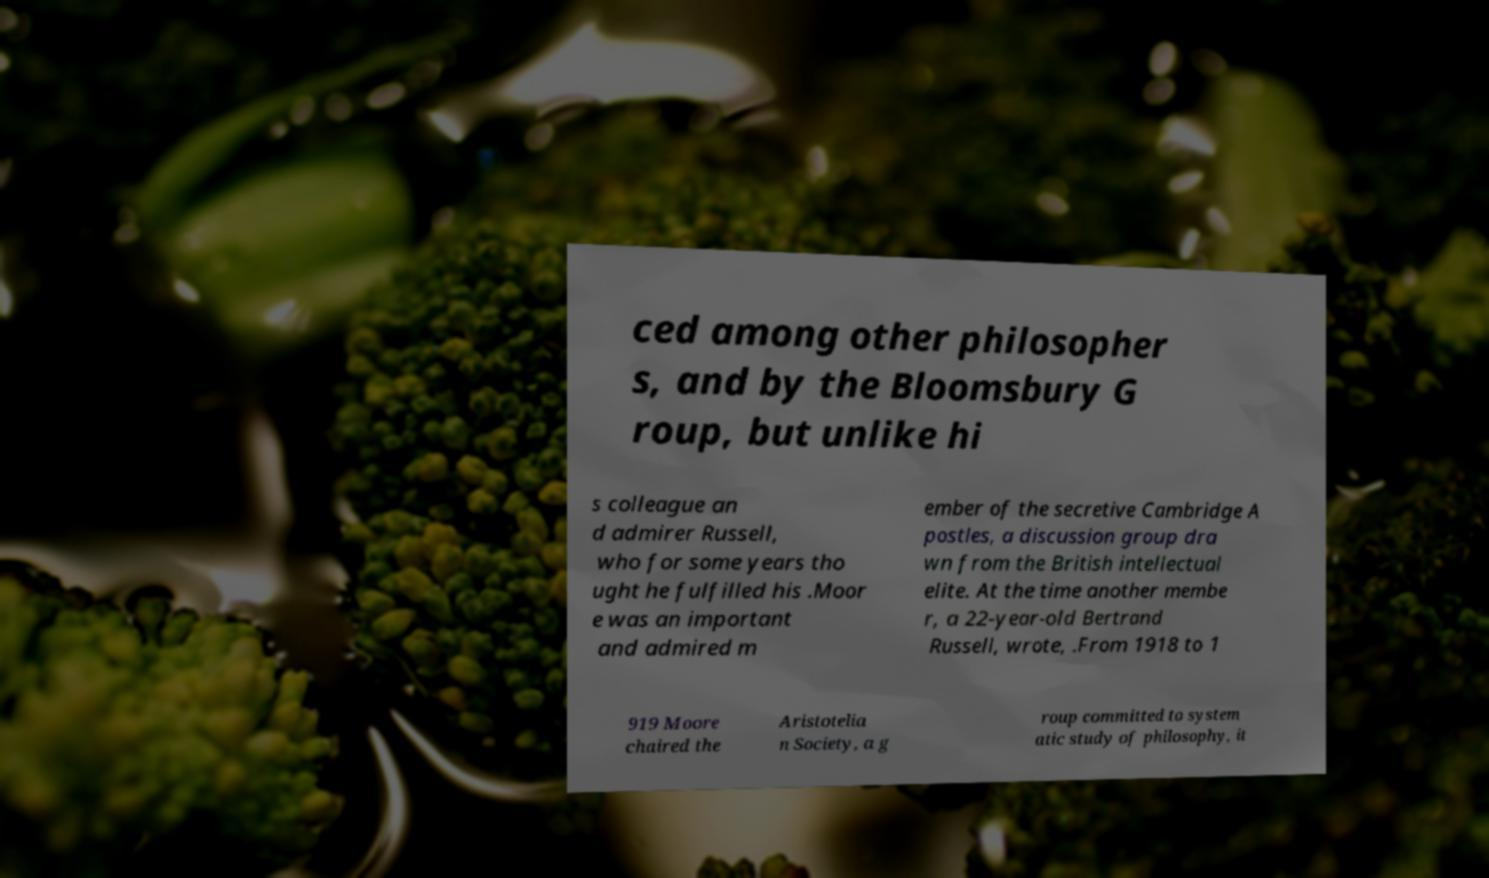Please identify and transcribe the text found in this image. ced among other philosopher s, and by the Bloomsbury G roup, but unlike hi s colleague an d admirer Russell, who for some years tho ught he fulfilled his .Moor e was an important and admired m ember of the secretive Cambridge A postles, a discussion group dra wn from the British intellectual elite. At the time another membe r, a 22-year-old Bertrand Russell, wrote, .From 1918 to 1 919 Moore chaired the Aristotelia n Society, a g roup committed to system atic study of philosophy, it 